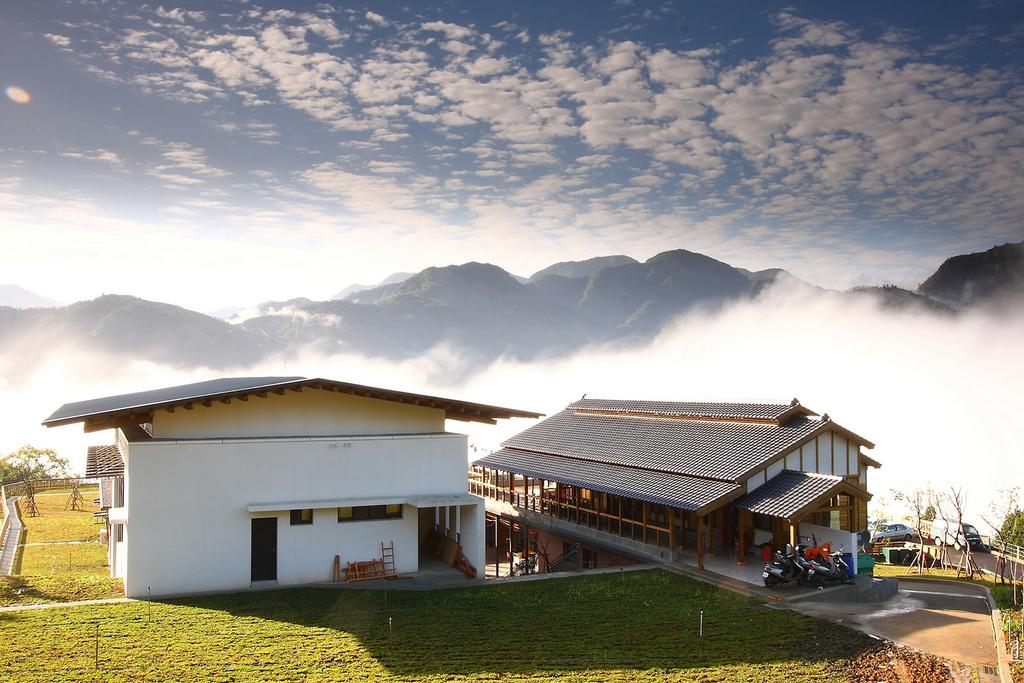What type of structures can be seen in the image? There are buildings in the image. What else can be found in the image besides buildings? There are vehicles parked and grass visible in the image. What is the terrain like in the image? There are hills in the image, and there is snow present. What is the weather like in the image? The sky is clouded in the image. Where are the tomatoes being grown in the image? There are no tomatoes present in the image. What type of flame can be seen coming from the buildings in the image? There is no flame present in the image; the buildings are not on fire. 